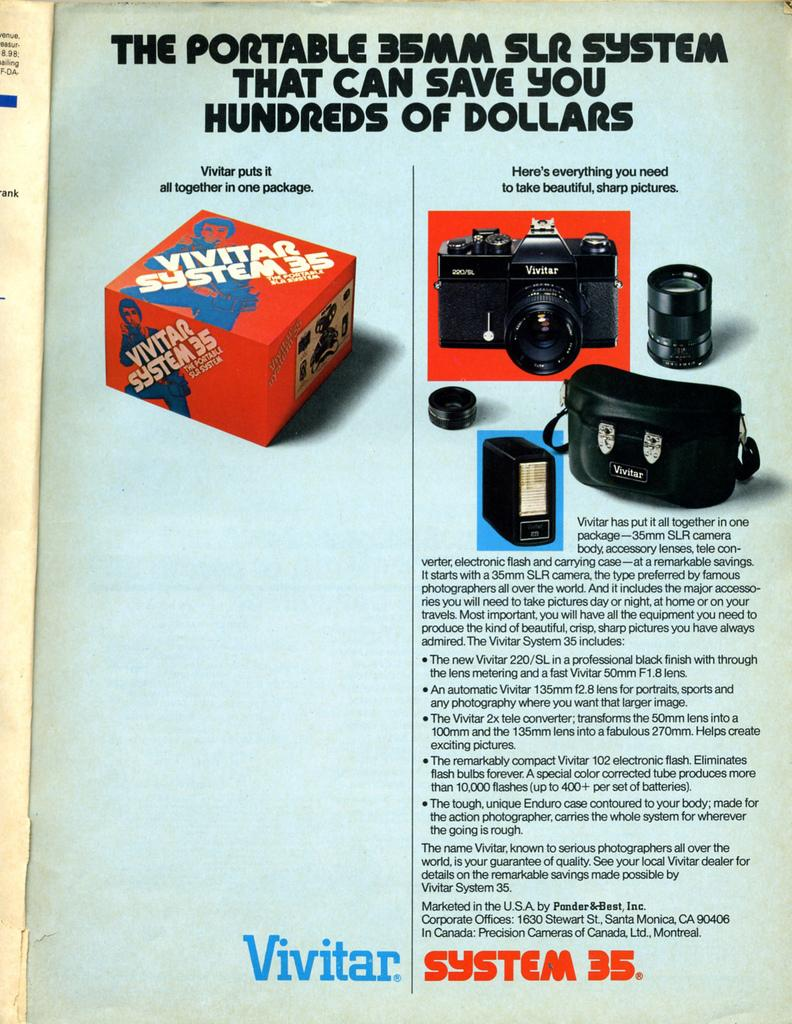What type of equipment is visible in the image? There are cameras in the image. What parts of the cameras are visible in the image? There are lenses in the image. What else can be seen in the image besides cameras and lenses? There are lights and a box visible in the image. Is there any text present in the image? Yes, there is text at the bottom of the image. How many spiders are crawling on the cameras in the image? There are no spiders present in the image. What color is the balloon tied to the box in the image? There is no balloon present in the image. 